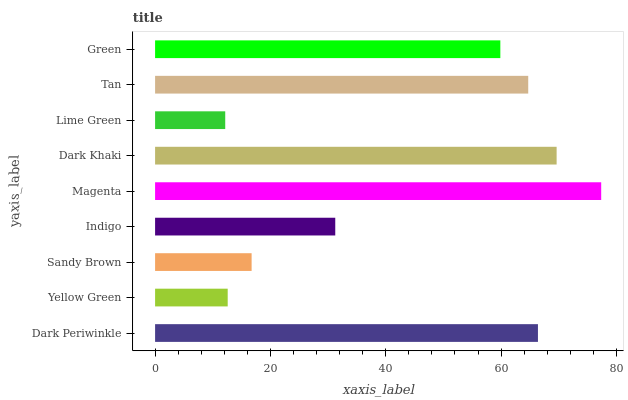Is Lime Green the minimum?
Answer yes or no. Yes. Is Magenta the maximum?
Answer yes or no. Yes. Is Yellow Green the minimum?
Answer yes or no. No. Is Yellow Green the maximum?
Answer yes or no. No. Is Dark Periwinkle greater than Yellow Green?
Answer yes or no. Yes. Is Yellow Green less than Dark Periwinkle?
Answer yes or no. Yes. Is Yellow Green greater than Dark Periwinkle?
Answer yes or no. No. Is Dark Periwinkle less than Yellow Green?
Answer yes or no. No. Is Green the high median?
Answer yes or no. Yes. Is Green the low median?
Answer yes or no. Yes. Is Tan the high median?
Answer yes or no. No. Is Dark Periwinkle the low median?
Answer yes or no. No. 